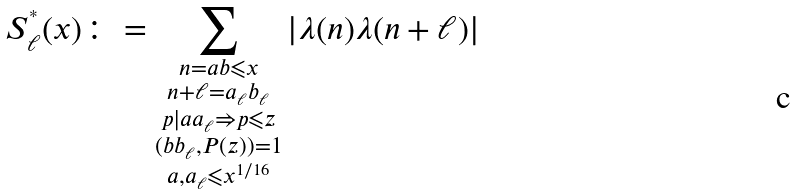<formula> <loc_0><loc_0><loc_500><loc_500>S ^ { ^ { * } } _ { \ell } ( x ) \colon = \sum _ { \substack { n = a b \leqslant x \\ n + \ell = a _ { \ell } b _ { \ell } \\ p | a a _ { \ell } \Rightarrow p \leqslant z \\ ( b b _ { \ell } , P ( z ) ) = 1 \\ a , a _ { \ell } \leqslant x ^ { 1 / 1 6 } } } | \lambda ( n ) \lambda ( n + \ell ) |</formula> 